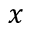<formula> <loc_0><loc_0><loc_500><loc_500>x</formula> 